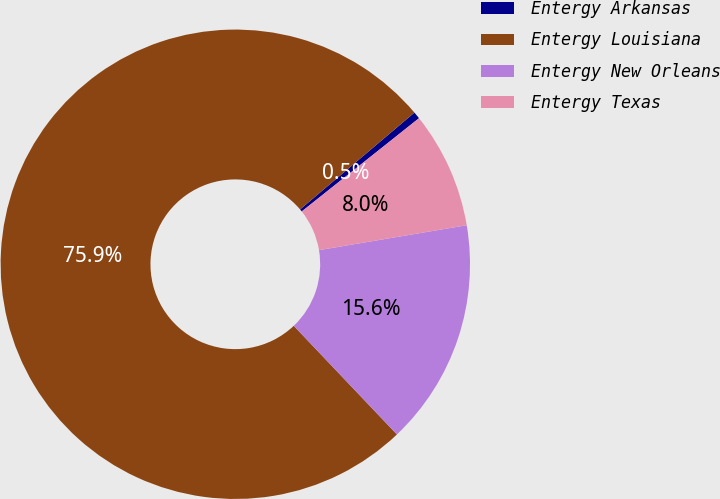Convert chart. <chart><loc_0><loc_0><loc_500><loc_500><pie_chart><fcel>Entergy Arkansas<fcel>Entergy Louisiana<fcel>Entergy New Orleans<fcel>Entergy Texas<nl><fcel>0.49%<fcel>75.9%<fcel>15.57%<fcel>8.03%<nl></chart> 